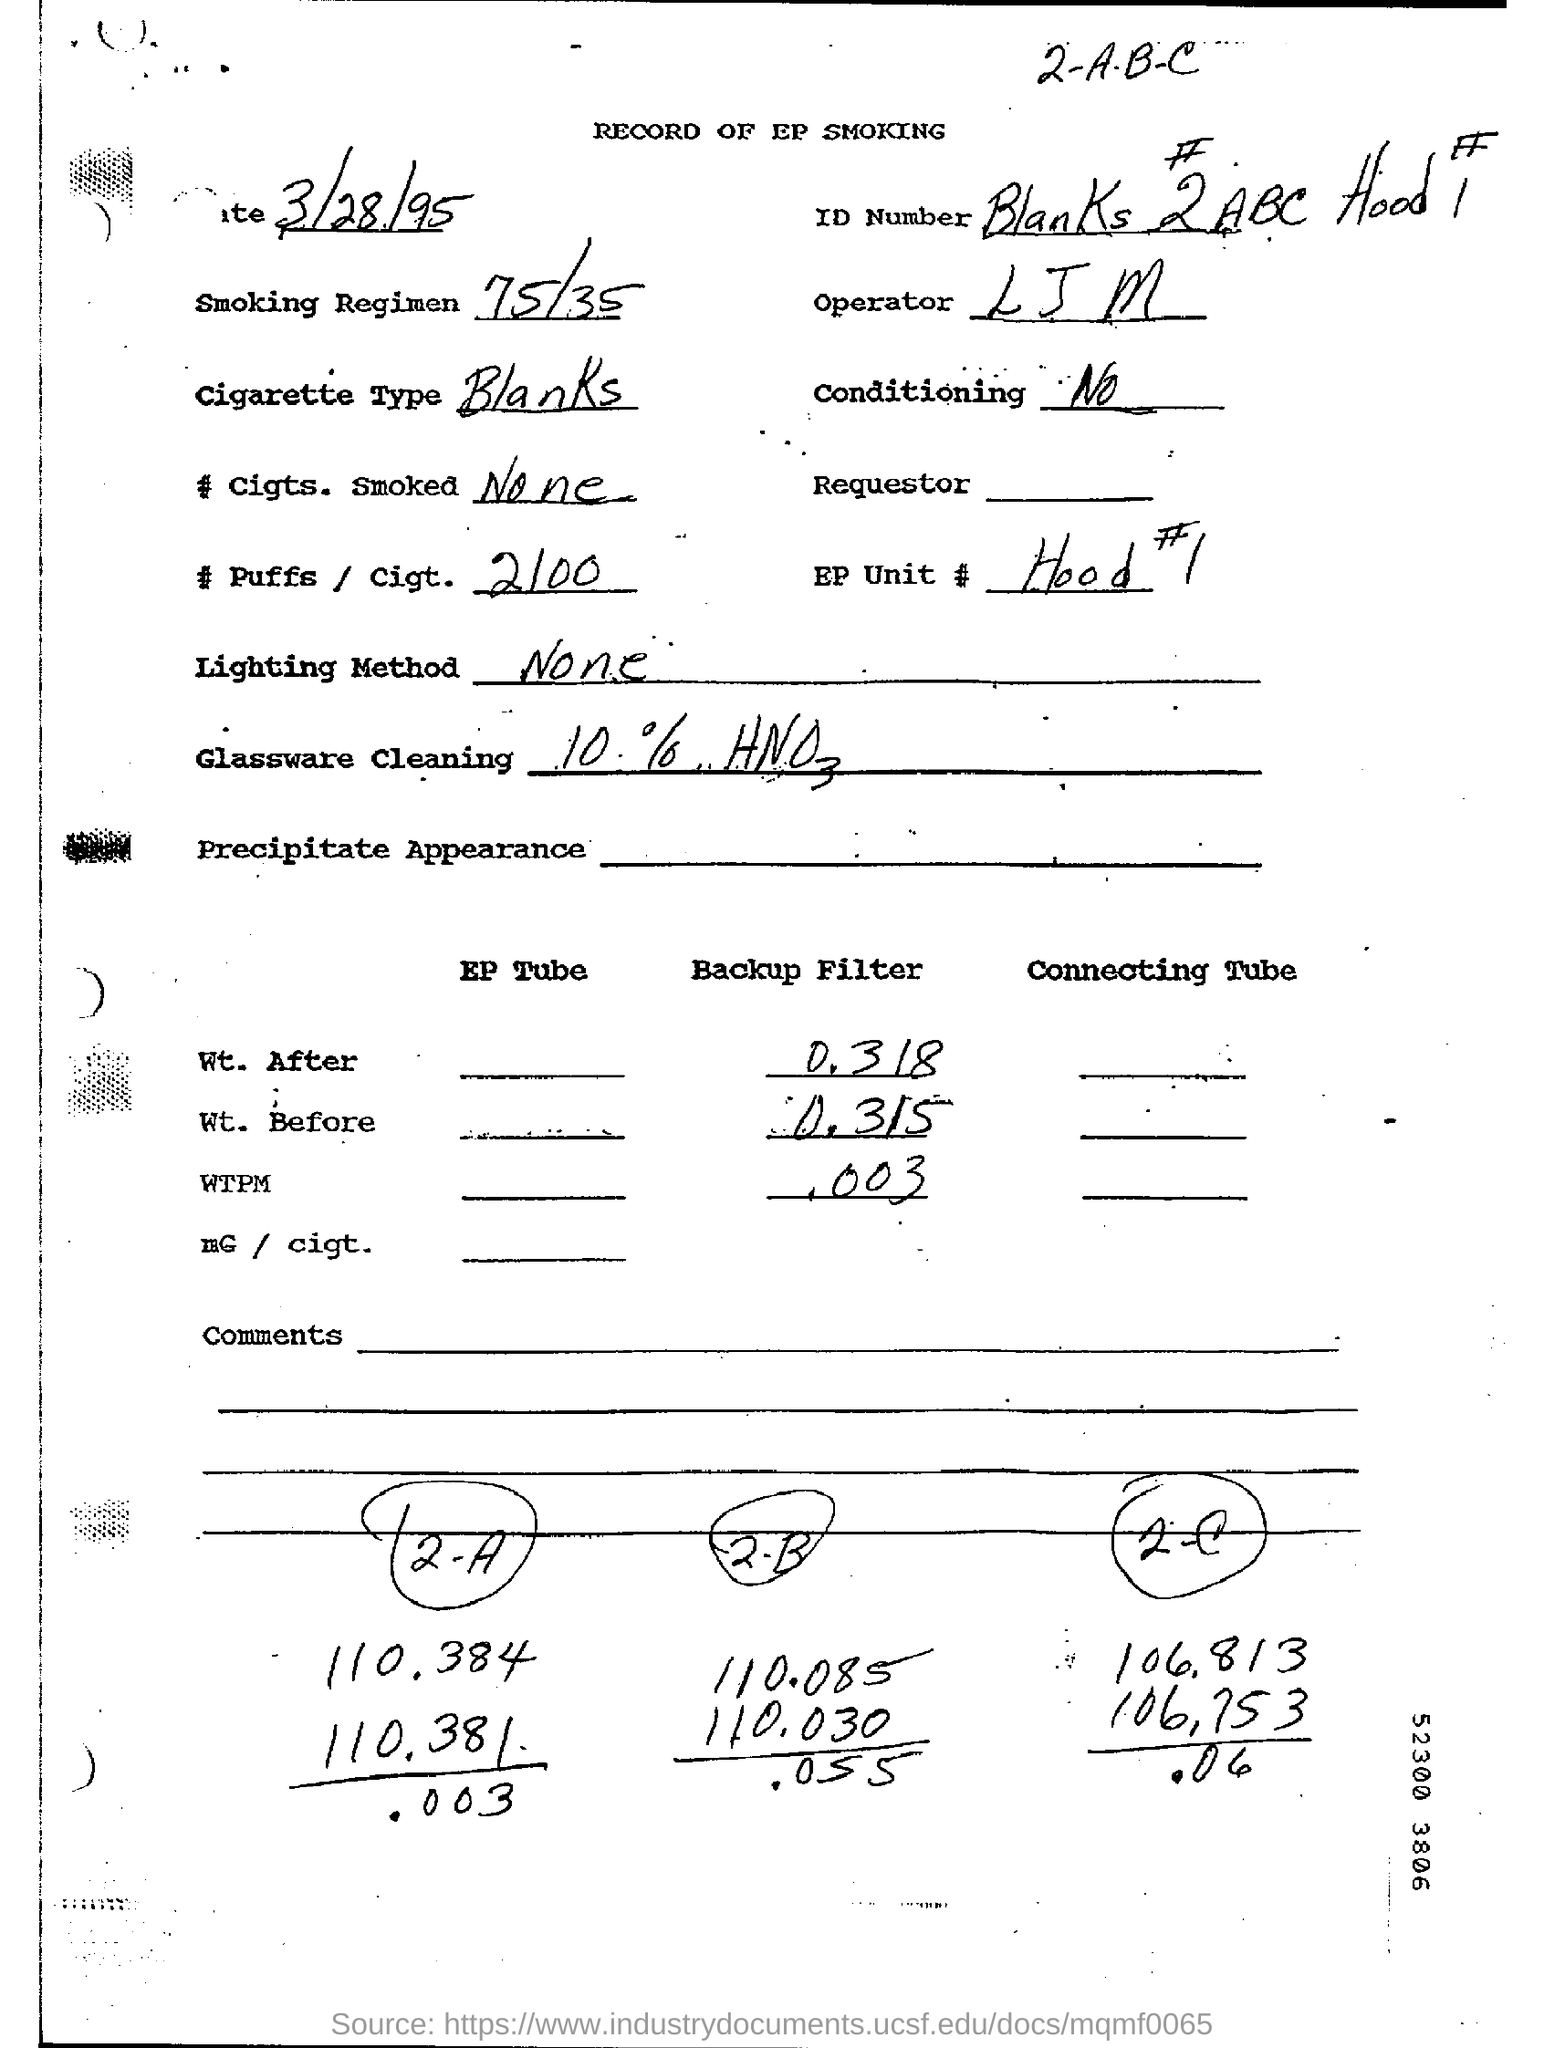Highlight a few significant elements in this photo. The type of cigarette is unknown, please provide more information. The smoking regimen refers to the specific method and ratio of smoking tobacco, often denoted as 75/35, which involves smoking 75% of the tobacco at a time and then letting it rest for 35 minutes before smoking the remaining 25%. 